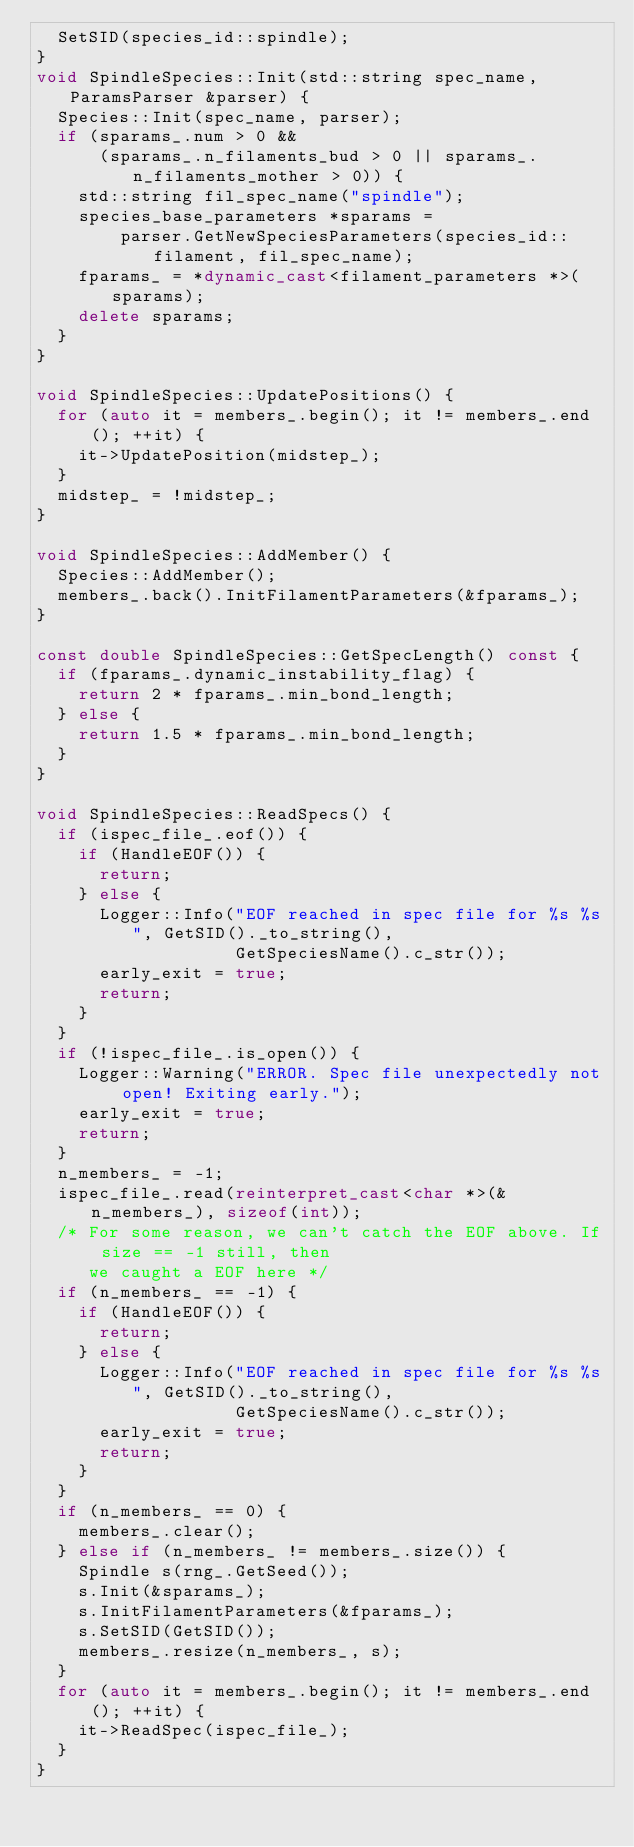<code> <loc_0><loc_0><loc_500><loc_500><_C++_>  SetSID(species_id::spindle);
}
void SpindleSpecies::Init(std::string spec_name, ParamsParser &parser) {
  Species::Init(spec_name, parser);
  if (sparams_.num > 0 &&
      (sparams_.n_filaments_bud > 0 || sparams_.n_filaments_mother > 0)) {
    std::string fil_spec_name("spindle");
    species_base_parameters *sparams =
        parser.GetNewSpeciesParameters(species_id::filament, fil_spec_name);
    fparams_ = *dynamic_cast<filament_parameters *>(sparams);
    delete sparams;
  }
}

void SpindleSpecies::UpdatePositions() {
  for (auto it = members_.begin(); it != members_.end(); ++it) {
    it->UpdatePosition(midstep_);
  }
  midstep_ = !midstep_;
}

void SpindleSpecies::AddMember() {
  Species::AddMember();
  members_.back().InitFilamentParameters(&fparams_);
}

const double SpindleSpecies::GetSpecLength() const { 
  if (fparams_.dynamic_instability_flag) {
    return 2 * fparams_.min_bond_length;
  } else {
    return 1.5 * fparams_.min_bond_length;
  }
}

void SpindleSpecies::ReadSpecs() {
  if (ispec_file_.eof()) {
    if (HandleEOF()) {
      return;
    } else {
      Logger::Info("EOF reached in spec file for %s %s", GetSID()._to_string(),
                   GetSpeciesName().c_str());
      early_exit = true;
      return;
    }
  }
  if (!ispec_file_.is_open()) {
    Logger::Warning("ERROR. Spec file unexpectedly not open! Exiting early.");
    early_exit = true;
    return;
  }
  n_members_ = -1;
  ispec_file_.read(reinterpret_cast<char *>(&n_members_), sizeof(int));
  /* For some reason, we can't catch the EOF above. If size == -1 still, then
     we caught a EOF here */
  if (n_members_ == -1) {
    if (HandleEOF()) {
      return;
    } else {
      Logger::Info("EOF reached in spec file for %s %s", GetSID()._to_string(),
                   GetSpeciesName().c_str());
      early_exit = true;
      return;
    }
  }
  if (n_members_ == 0) {
    members_.clear();
  } else if (n_members_ != members_.size()) {
    Spindle s(rng_.GetSeed());
    s.Init(&sparams_);
    s.InitFilamentParameters(&fparams_);
    s.SetSID(GetSID());
    members_.resize(n_members_, s);
  }
  for (auto it = members_.begin(); it != members_.end(); ++it) {
    it->ReadSpec(ispec_file_);
  }
}



</code> 